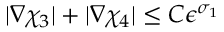<formula> <loc_0><loc_0><loc_500><loc_500>| \nabla \chi _ { 3 } | + | \nabla \chi _ { 4 } | \leq C \epsilon ^ { \sigma _ { 1 } }</formula> 